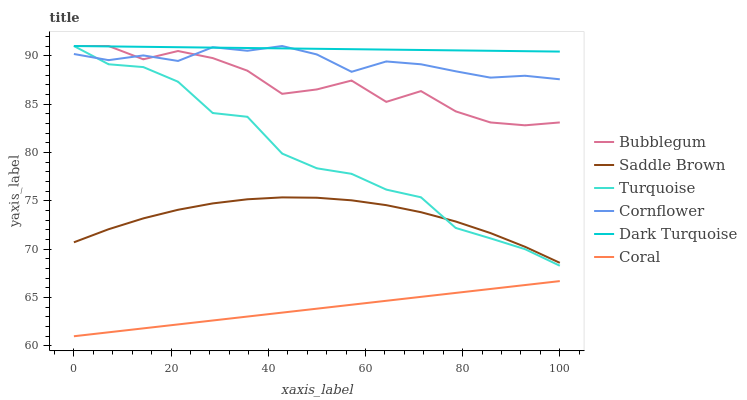Does Turquoise have the minimum area under the curve?
Answer yes or no. No. Does Turquoise have the maximum area under the curve?
Answer yes or no. No. Is Turquoise the smoothest?
Answer yes or no. No. Is Turquoise the roughest?
Answer yes or no. No. Does Turquoise have the lowest value?
Answer yes or no. No. Does Coral have the highest value?
Answer yes or no. No. Is Saddle Brown less than Dark Turquoise?
Answer yes or no. Yes. Is Saddle Brown greater than Coral?
Answer yes or no. Yes. Does Saddle Brown intersect Dark Turquoise?
Answer yes or no. No. 